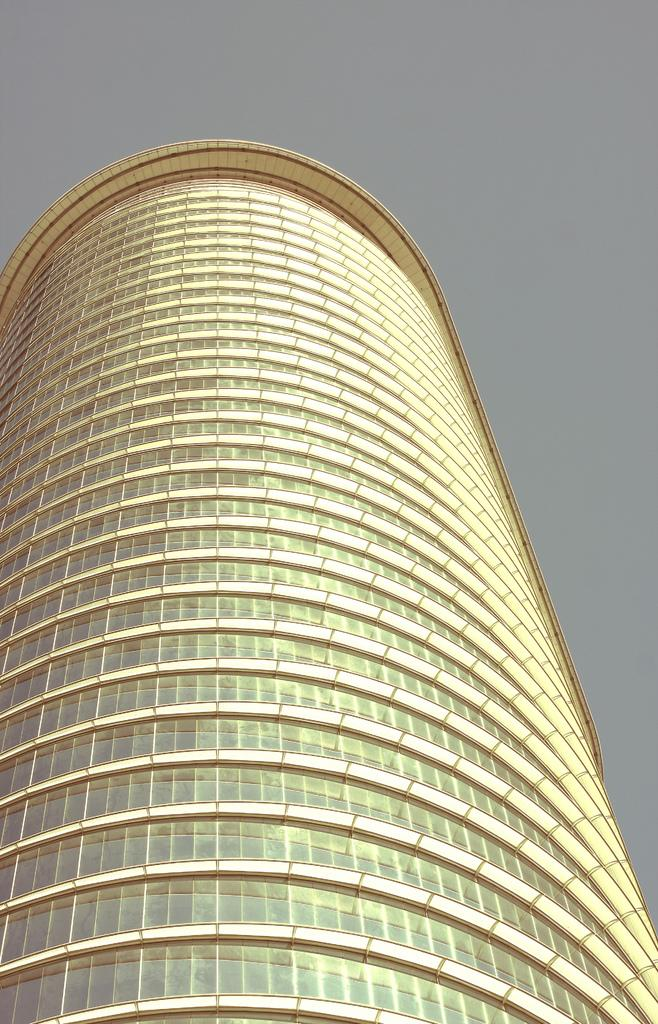What is the main subject of the image? There is a skyscraper in the center of the image. Can you describe the skyscraper in the image? The skyscraper is the main subject and is located in the center of the image. What type of structure is the skyscraper? The skyscraper is a tall building, typically used for commercial or residential purposes. What type of attraction is located on the street near the skyscraper in the image? There is no street or attraction mentioned in the image; it only features a skyscraper. How many spoons are visible in the image? There are no spoons present in the image. 